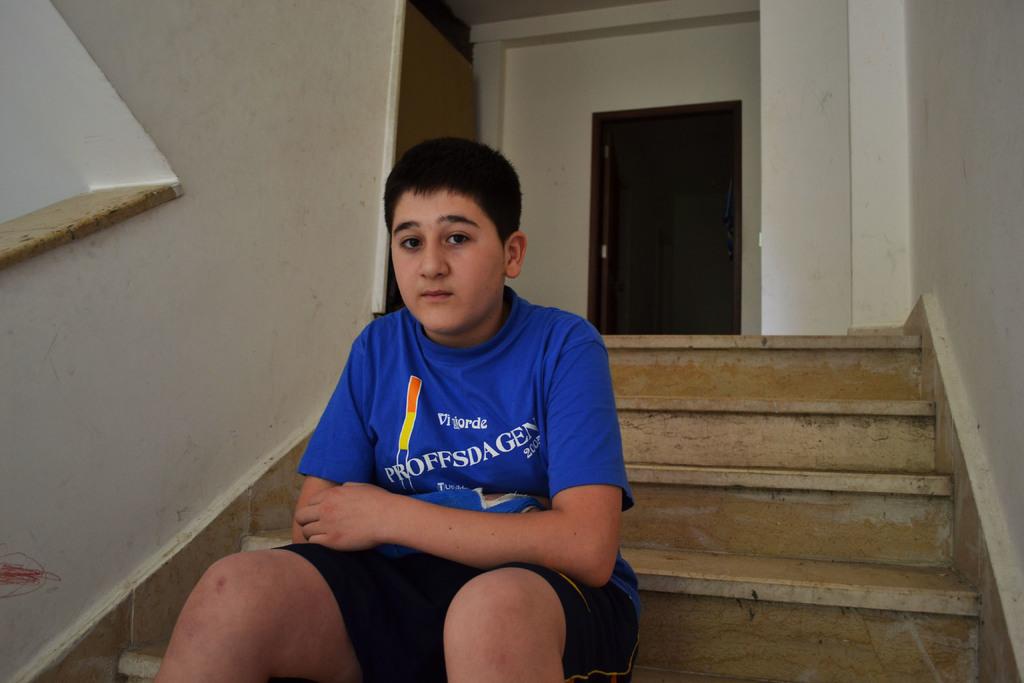What is written on the boy's shirt?
Keep it short and to the point. Proffsdagen. 